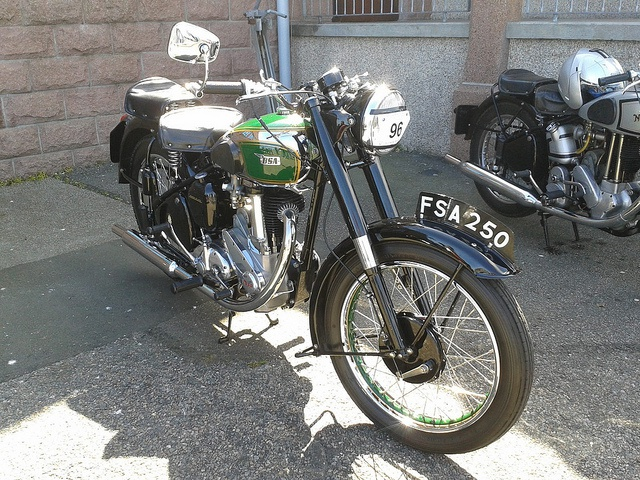Describe the objects in this image and their specific colors. I can see motorcycle in gray, black, white, and darkgray tones and motorcycle in gray, black, darkgray, and darkblue tones in this image. 